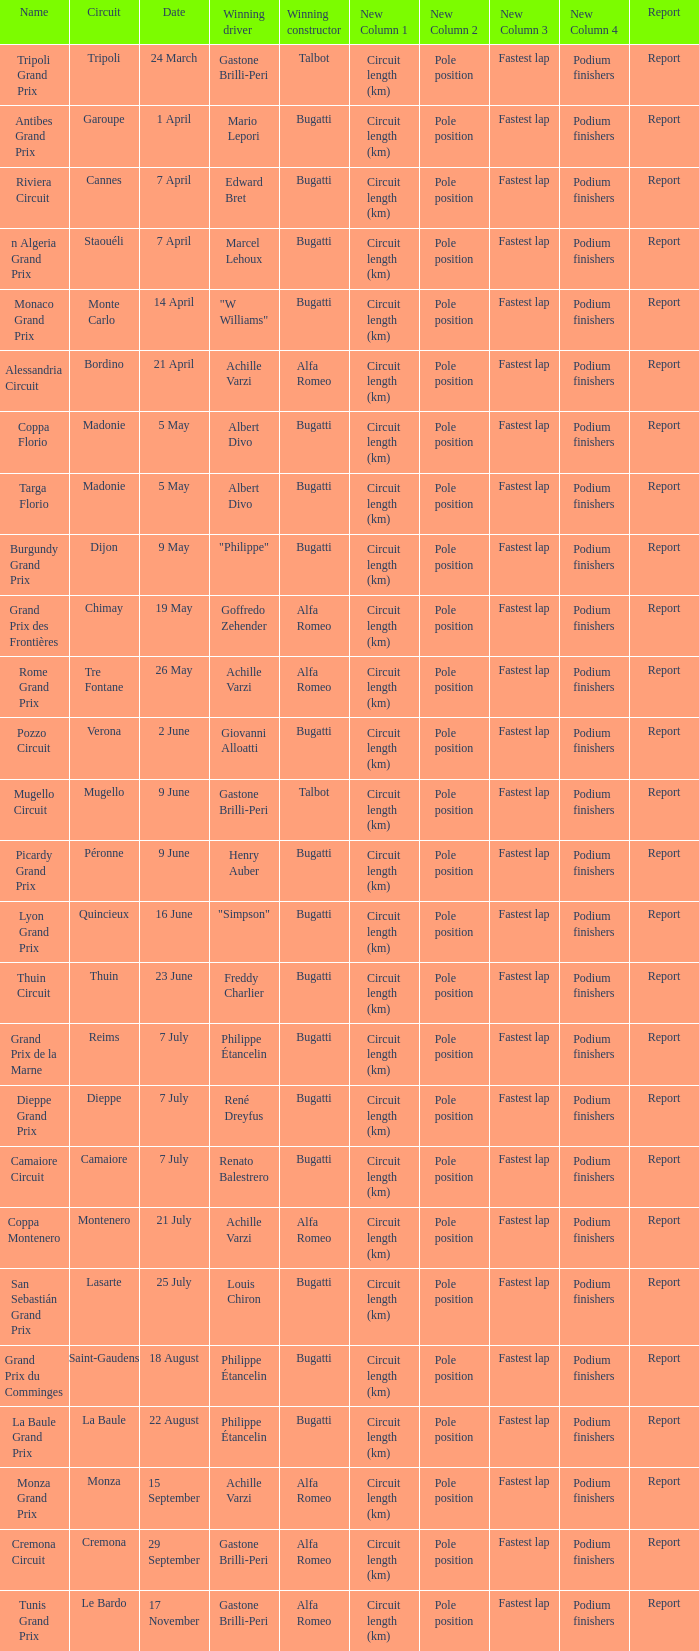What Winning driver has a Winning constructor of talbot? Gastone Brilli-Peri, Gastone Brilli-Peri. 